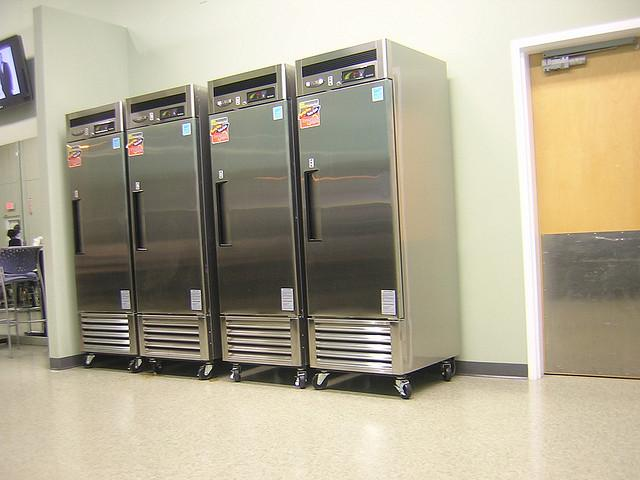Where is this scene taking place?

Choices:
A) house
B) store
C) cafeteria
D) furniture store cafeteria 